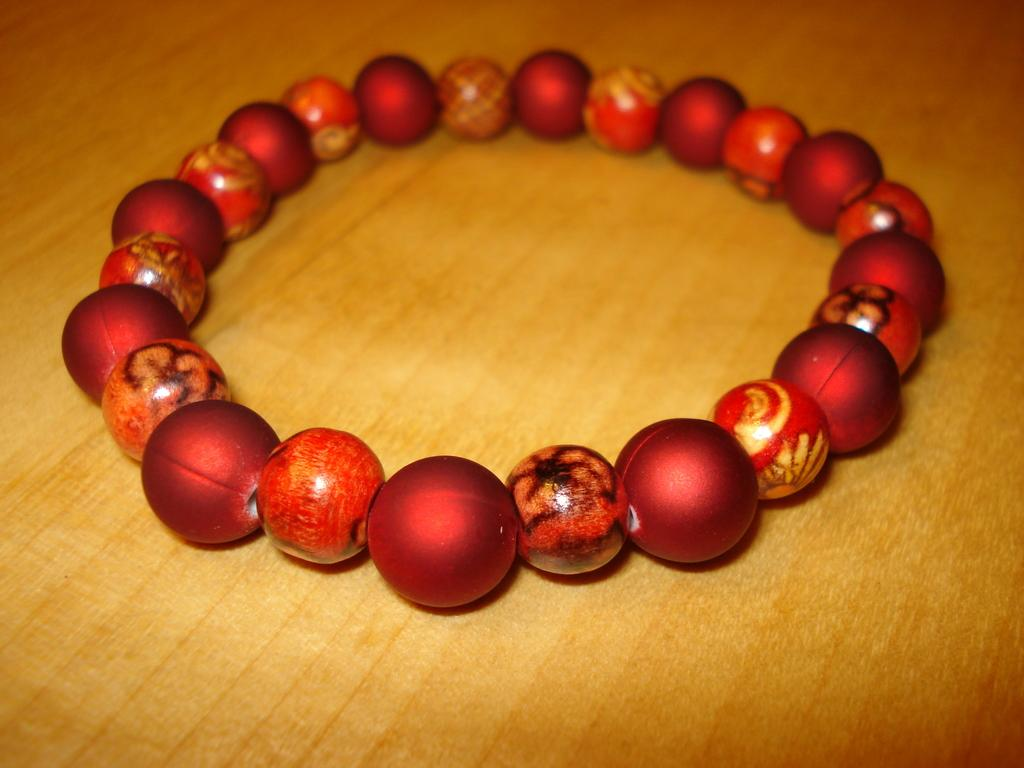What is the main object in the image? There is a bracelet in the image. Where is the bracelet located? The bracelet is placed on a wooden floor. How is the bracelet positioned in the image? The bracelet is in the middle of the image. What type of pet can be seen holding the bracelet in the image? There is no pet present in the image, and the bracelet is not being held by any animal. 